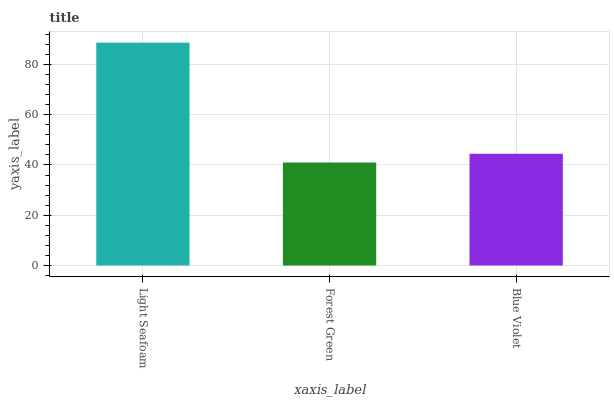Is Forest Green the minimum?
Answer yes or no. Yes. Is Light Seafoam the maximum?
Answer yes or no. Yes. Is Blue Violet the minimum?
Answer yes or no. No. Is Blue Violet the maximum?
Answer yes or no. No. Is Blue Violet greater than Forest Green?
Answer yes or no. Yes. Is Forest Green less than Blue Violet?
Answer yes or no. Yes. Is Forest Green greater than Blue Violet?
Answer yes or no. No. Is Blue Violet less than Forest Green?
Answer yes or no. No. Is Blue Violet the high median?
Answer yes or no. Yes. Is Blue Violet the low median?
Answer yes or no. Yes. Is Light Seafoam the high median?
Answer yes or no. No. Is Light Seafoam the low median?
Answer yes or no. No. 